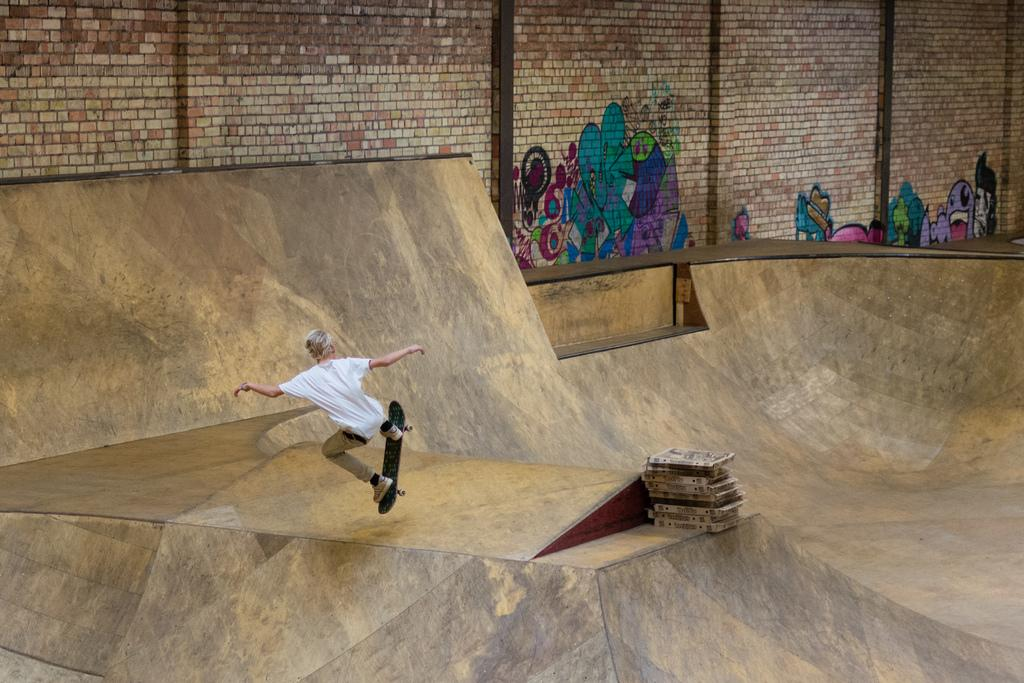What is the main subject of the image? There is a person in the image. What is the person doing in the image? The person is skating on a curved floor. What can be seen on the walls in the image? There are paintings on the wall in the image. Can you see a snake in the image? There is no snake present in the image. 